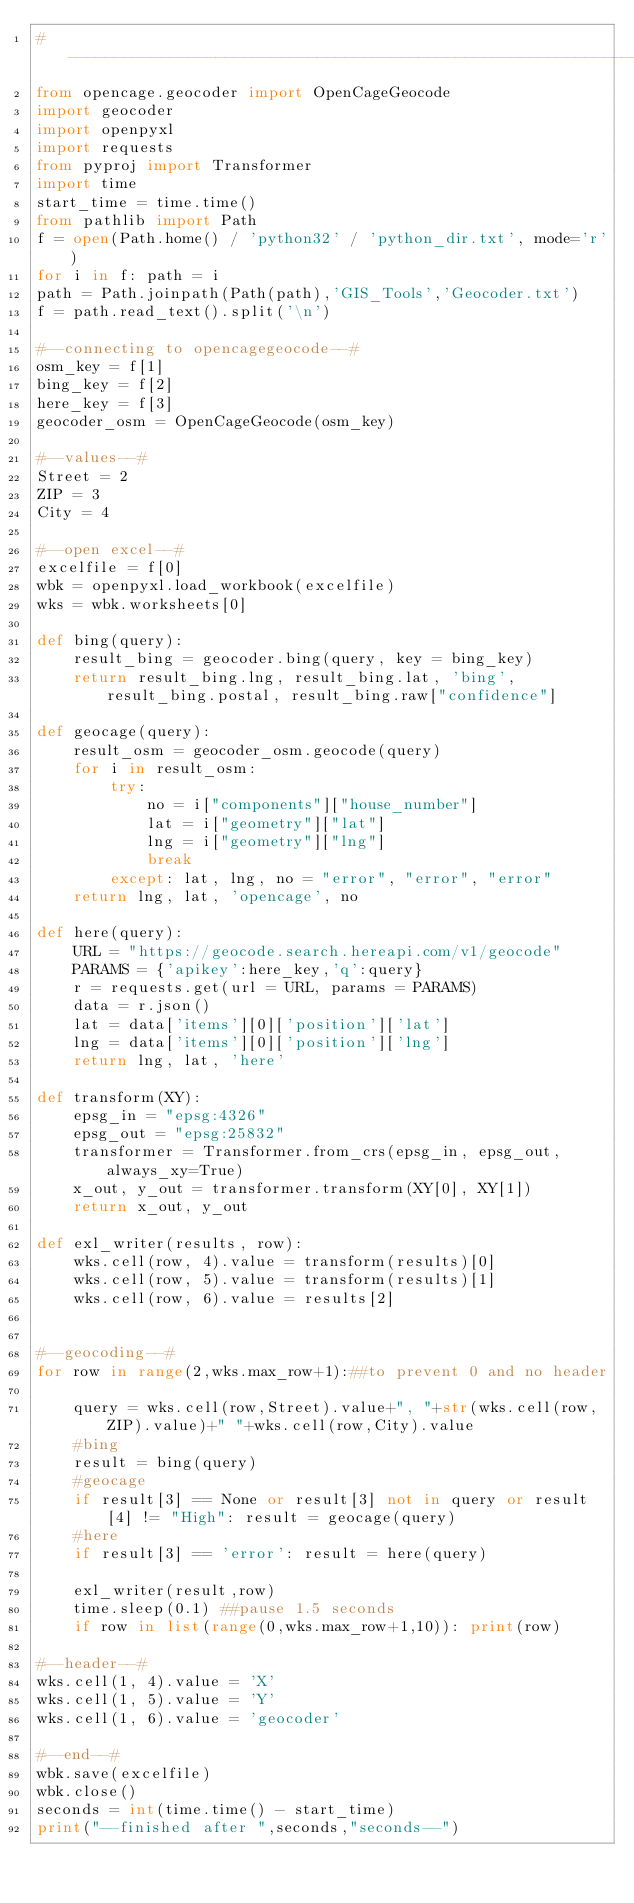<code> <loc_0><loc_0><loc_500><loc_500><_Python_>#-------------------------------------------------------------------------------
from opencage.geocoder import OpenCageGeocode
import geocoder
import openpyxl
import requests
from pyproj import Transformer
import time
start_time = time.time()
from pathlib import Path
f = open(Path.home() / 'python32' / 'python_dir.txt', mode='r')
for i in f: path = i
path = Path.joinpath(Path(path),'GIS_Tools','Geocoder.txt')
f = path.read_text().split('\n')

#--connecting to opencagegeocode--#
osm_key = f[1]
bing_key = f[2]
here_key = f[3]
geocoder_osm = OpenCageGeocode(osm_key)

#--values--#
Street = 2
ZIP = 3
City = 4

#--open excel--#
excelfile = f[0]
wbk = openpyxl.load_workbook(excelfile)
wks = wbk.worksheets[0]

def bing(query):
    result_bing = geocoder.bing(query, key = bing_key)
    return result_bing.lng, result_bing.lat, 'bing', result_bing.postal, result_bing.raw["confidence"]

def geocage(query):
    result_osm = geocoder_osm.geocode(query)
    for i in result_osm:
        try:
            no = i["components"]["house_number"]
            lat = i["geometry"]["lat"]
            lng = i["geometry"]["lng"]
            break
        except: lat, lng, no = "error", "error", "error"
    return lng, lat, 'opencage', no

def here(query):
    URL = "https://geocode.search.hereapi.com/v1/geocode"
    PARAMS = {'apikey':here_key,'q':query}
    r = requests.get(url = URL, params = PARAMS)
    data = r.json()
    lat = data['items'][0]['position']['lat']
    lng = data['items'][0]['position']['lng']
    return lng, lat, 'here'

def transform(XY):
    epsg_in = "epsg:4326"
    epsg_out = "epsg:25832"
    transformer = Transformer.from_crs(epsg_in, epsg_out, always_xy=True)
    x_out, y_out = transformer.transform(XY[0], XY[1])
    return x_out, y_out

def exl_writer(results, row):
    wks.cell(row, 4).value = transform(results)[0]
    wks.cell(row, 5).value = transform(results)[1]
    wks.cell(row, 6).value = results[2]


#--geocoding--#
for row in range(2,wks.max_row+1):##to prevent 0 and no header

    query = wks.cell(row,Street).value+", "+str(wks.cell(row,ZIP).value)+" "+wks.cell(row,City).value
    #bing
    result = bing(query)
    #geocage
    if result[3] == None or result[3] not in query or result[4] != "High": result = geocage(query)
    #here
    if result[3] == 'error': result = here(query)

    exl_writer(result,row)
    time.sleep(0.1) ##pause 1.5 seconds
    if row in list(range(0,wks.max_row+1,10)): print(row)

#--header--#
wks.cell(1, 4).value = 'X'
wks.cell(1, 5).value = 'Y'
wks.cell(1, 6).value = 'geocoder'

#--end--#
wbk.save(excelfile)
wbk.close()
seconds = int(time.time() - start_time)
print("--finished after ",seconds,"seconds--")</code> 